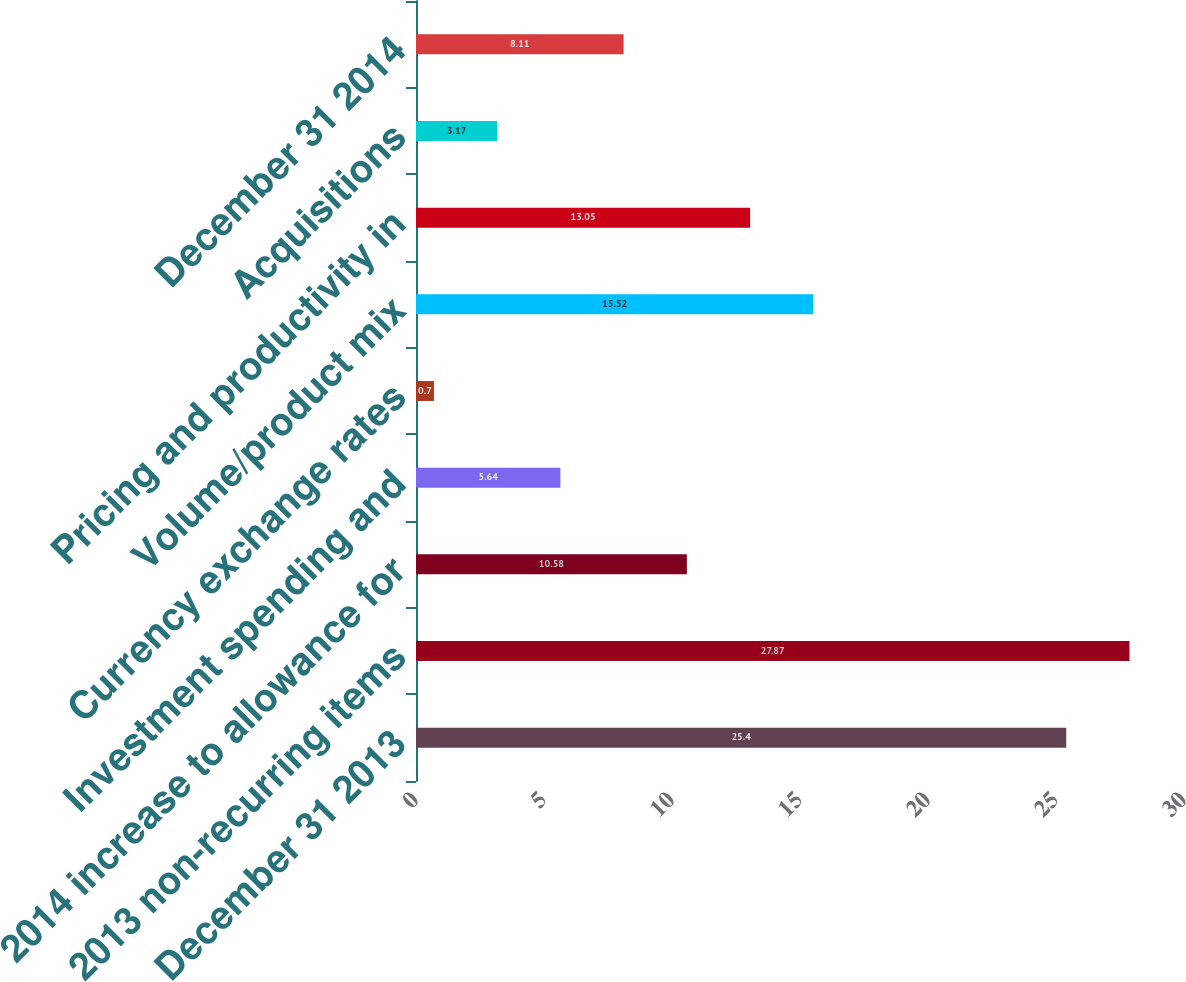Convert chart to OTSL. <chart><loc_0><loc_0><loc_500><loc_500><bar_chart><fcel>December 31 2013<fcel>2013 non-recurring items<fcel>2014 increase to allowance for<fcel>Investment spending and<fcel>Currency exchange rates<fcel>Volume/product mix<fcel>Pricing and productivity in<fcel>Acquisitions<fcel>December 31 2014<nl><fcel>25.4<fcel>27.87<fcel>10.58<fcel>5.64<fcel>0.7<fcel>15.52<fcel>13.05<fcel>3.17<fcel>8.11<nl></chart> 